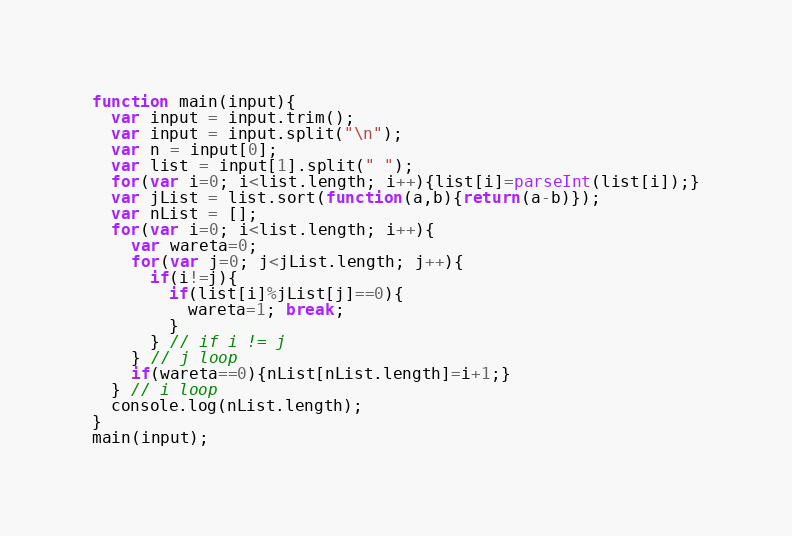Convert code to text. <code><loc_0><loc_0><loc_500><loc_500><_JavaScript_>function main(input){
  var input = input.trim();
  var input = input.split("\n");
  var n = input[0];
  var list = input[1].split(" ");
  for(var i=0; i<list.length; i++){list[i]=parseInt(list[i]);}
  var jList = list.sort(function(a,b){return(a-b)});
  var nList = [];
  for(var i=0; i<list.length; i++){
    var wareta=0;
    for(var j=0; j<jList.length; j++){
      if(i!=j){
        if(list[i]%jList[j]==0){
          wareta=1; break;
        }
      } // if i != j
    } // j loop
    if(wareta==0){nList[nList.length]=i+1;}
  } // i loop
  console.log(nList.length);
}
main(input);</code> 